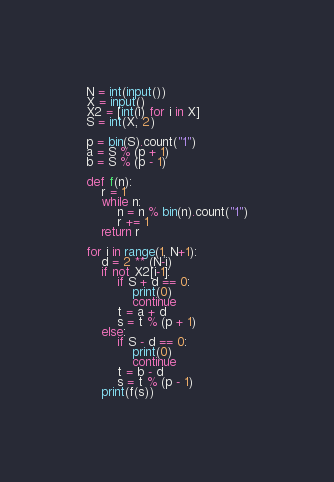Convert code to text. <code><loc_0><loc_0><loc_500><loc_500><_Python_>N = int(input())
X = input()
X2 = [int(i) for i in X]
S = int(X, 2)

p = bin(S).count("1")
a = S % (p + 1)
b = S % (p - 1)

def f(n):
    r = 1
    while n:
        n = n % bin(n).count("1")
        r += 1
    return r

for i in range(1, N+1):
    d = 2 ** (N-i)
    if not X2[i-1]:
        if S + d == 0:
            print(0)
            continue
        t = a + d
        s = t % (p + 1)
    else:
        if S - d == 0:
            print(0)
            continue
        t = b - d
        s = t % (p - 1)
    print(f(s))

</code> 